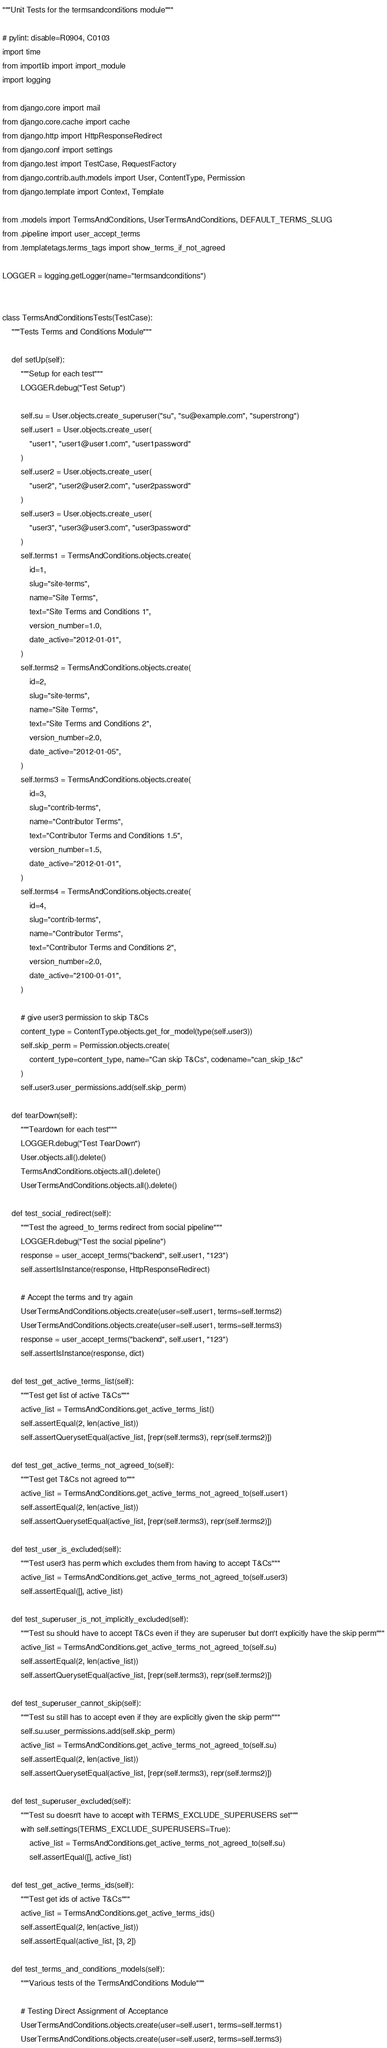<code> <loc_0><loc_0><loc_500><loc_500><_Python_>"""Unit Tests for the termsandconditions module"""

# pylint: disable=R0904, C0103
import time
from importlib import import_module
import logging

from django.core import mail
from django.core.cache import cache
from django.http import HttpResponseRedirect
from django.conf import settings
from django.test import TestCase, RequestFactory
from django.contrib.auth.models import User, ContentType, Permission
from django.template import Context, Template

from .models import TermsAndConditions, UserTermsAndConditions, DEFAULT_TERMS_SLUG
from .pipeline import user_accept_terms
from .templatetags.terms_tags import show_terms_if_not_agreed

LOGGER = logging.getLogger(name="termsandconditions")


class TermsAndConditionsTests(TestCase):
    """Tests Terms and Conditions Module"""

    def setUp(self):
        """Setup for each test"""
        LOGGER.debug("Test Setup")

        self.su = User.objects.create_superuser("su", "su@example.com", "superstrong")
        self.user1 = User.objects.create_user(
            "user1", "user1@user1.com", "user1password"
        )
        self.user2 = User.objects.create_user(
            "user2", "user2@user2.com", "user2password"
        )
        self.user3 = User.objects.create_user(
            "user3", "user3@user3.com", "user3password"
        )
        self.terms1 = TermsAndConditions.objects.create(
            id=1,
            slug="site-terms",
            name="Site Terms",
            text="Site Terms and Conditions 1",
            version_number=1.0,
            date_active="2012-01-01",
        )
        self.terms2 = TermsAndConditions.objects.create(
            id=2,
            slug="site-terms",
            name="Site Terms",
            text="Site Terms and Conditions 2",
            version_number=2.0,
            date_active="2012-01-05",
        )
        self.terms3 = TermsAndConditions.objects.create(
            id=3,
            slug="contrib-terms",
            name="Contributor Terms",
            text="Contributor Terms and Conditions 1.5",
            version_number=1.5,
            date_active="2012-01-01",
        )
        self.terms4 = TermsAndConditions.objects.create(
            id=4,
            slug="contrib-terms",
            name="Contributor Terms",
            text="Contributor Terms and Conditions 2",
            version_number=2.0,
            date_active="2100-01-01",
        )

        # give user3 permission to skip T&Cs
        content_type = ContentType.objects.get_for_model(type(self.user3))
        self.skip_perm = Permission.objects.create(
            content_type=content_type, name="Can skip T&Cs", codename="can_skip_t&c"
        )
        self.user3.user_permissions.add(self.skip_perm)

    def tearDown(self):
        """Teardown for each test"""
        LOGGER.debug("Test TearDown")
        User.objects.all().delete()
        TermsAndConditions.objects.all().delete()
        UserTermsAndConditions.objects.all().delete()

    def test_social_redirect(self):
        """Test the agreed_to_terms redirect from social pipeline"""
        LOGGER.debug("Test the social pipeline")
        response = user_accept_terms("backend", self.user1, "123")
        self.assertIsInstance(response, HttpResponseRedirect)

        # Accept the terms and try again
        UserTermsAndConditions.objects.create(user=self.user1, terms=self.terms2)
        UserTermsAndConditions.objects.create(user=self.user1, terms=self.terms3)
        response = user_accept_terms("backend", self.user1, "123")
        self.assertIsInstance(response, dict)

    def test_get_active_terms_list(self):
        """Test get list of active T&Cs"""
        active_list = TermsAndConditions.get_active_terms_list()
        self.assertEqual(2, len(active_list))
        self.assertQuerysetEqual(active_list, [repr(self.terms3), repr(self.terms2)])

    def test_get_active_terms_not_agreed_to(self):
        """Test get T&Cs not agreed to"""
        active_list = TermsAndConditions.get_active_terms_not_agreed_to(self.user1)
        self.assertEqual(2, len(active_list))
        self.assertQuerysetEqual(active_list, [repr(self.terms3), repr(self.terms2)])

    def test_user_is_excluded(self):
        """Test user3 has perm which excludes them from having to accept T&Cs"""
        active_list = TermsAndConditions.get_active_terms_not_agreed_to(self.user3)
        self.assertEqual([], active_list)

    def test_superuser_is_not_implicitly_excluded(self):
        """Test su should have to accept T&Cs even if they are superuser but don't explicitly have the skip perm"""
        active_list = TermsAndConditions.get_active_terms_not_agreed_to(self.su)
        self.assertEqual(2, len(active_list))
        self.assertQuerysetEqual(active_list, [repr(self.terms3), repr(self.terms2)])

    def test_superuser_cannot_skip(self):
        """Test su still has to accept even if they are explicitly given the skip perm"""
        self.su.user_permissions.add(self.skip_perm)
        active_list = TermsAndConditions.get_active_terms_not_agreed_to(self.su)
        self.assertEqual(2, len(active_list))
        self.assertQuerysetEqual(active_list, [repr(self.terms3), repr(self.terms2)])

    def test_superuser_excluded(self):
        """Test su doesn't have to accept with TERMS_EXCLUDE_SUPERUSERS set"""
        with self.settings(TERMS_EXCLUDE_SUPERUSERS=True):
            active_list = TermsAndConditions.get_active_terms_not_agreed_to(self.su)
            self.assertEqual([], active_list)

    def test_get_active_terms_ids(self):
        """Test get ids of active T&Cs"""
        active_list = TermsAndConditions.get_active_terms_ids()
        self.assertEqual(2, len(active_list))
        self.assertEqual(active_list, [3, 2])

    def test_terms_and_conditions_models(self):
        """Various tests of the TermsAndConditions Module"""

        # Testing Direct Assignment of Acceptance
        UserTermsAndConditions.objects.create(user=self.user1, terms=self.terms1)
        UserTermsAndConditions.objects.create(user=self.user2, terms=self.terms3)
</code> 